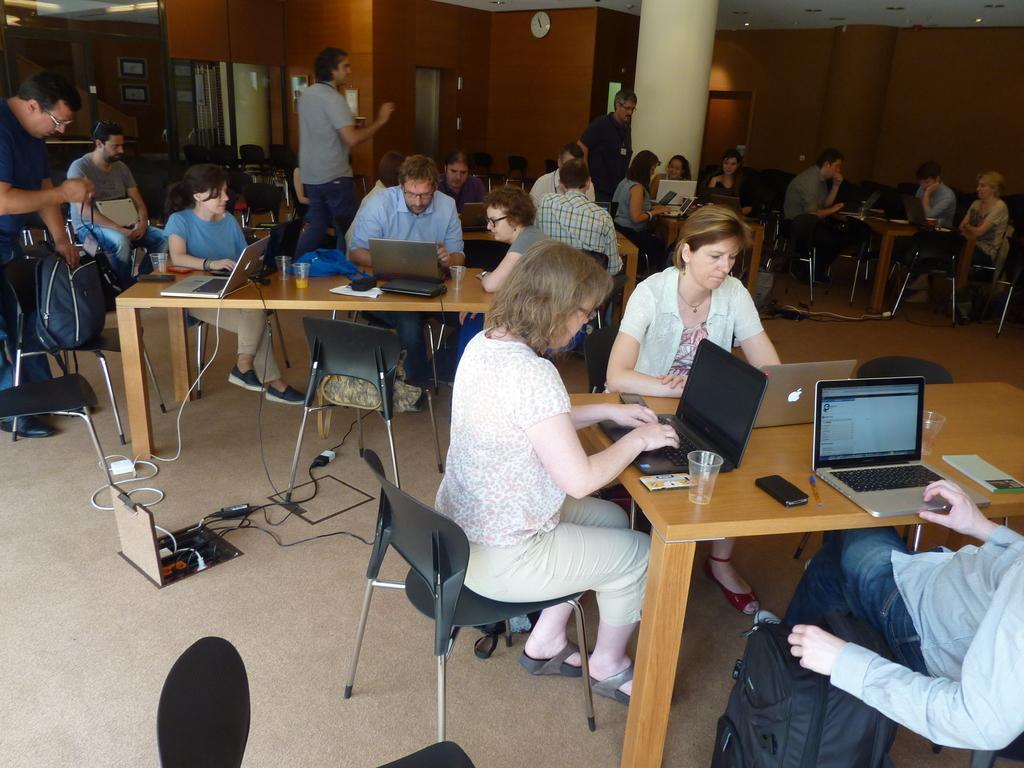Can you describe this image briefly? In the image we can see there are lot of people who are sitting on chair and on the table there are laptops and mobile phone. 